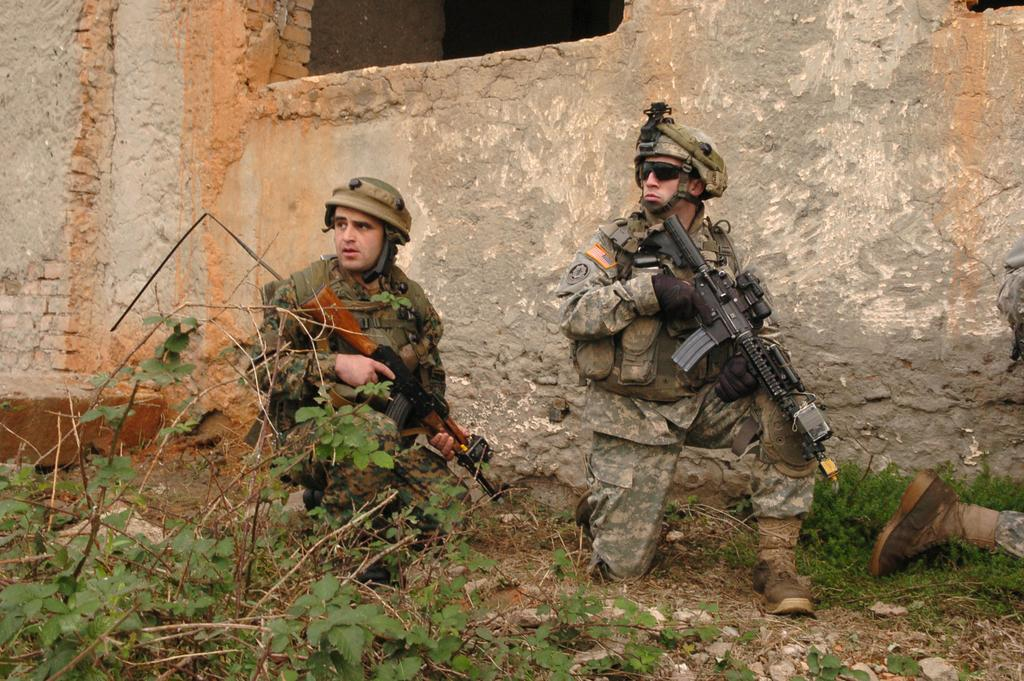Who or what is present in the image? There are people in the image. What are the people wearing? The people are wearing helmets. What are the people holding? The people are holding guns. What type of vegetation can be seen in the image? There are plants in the image. What kind of structure is visible in the image? There is a wall in the image. How does the alley contribute to the birthday celebration in the image? There is no alley or birthday celebration present in the image. 